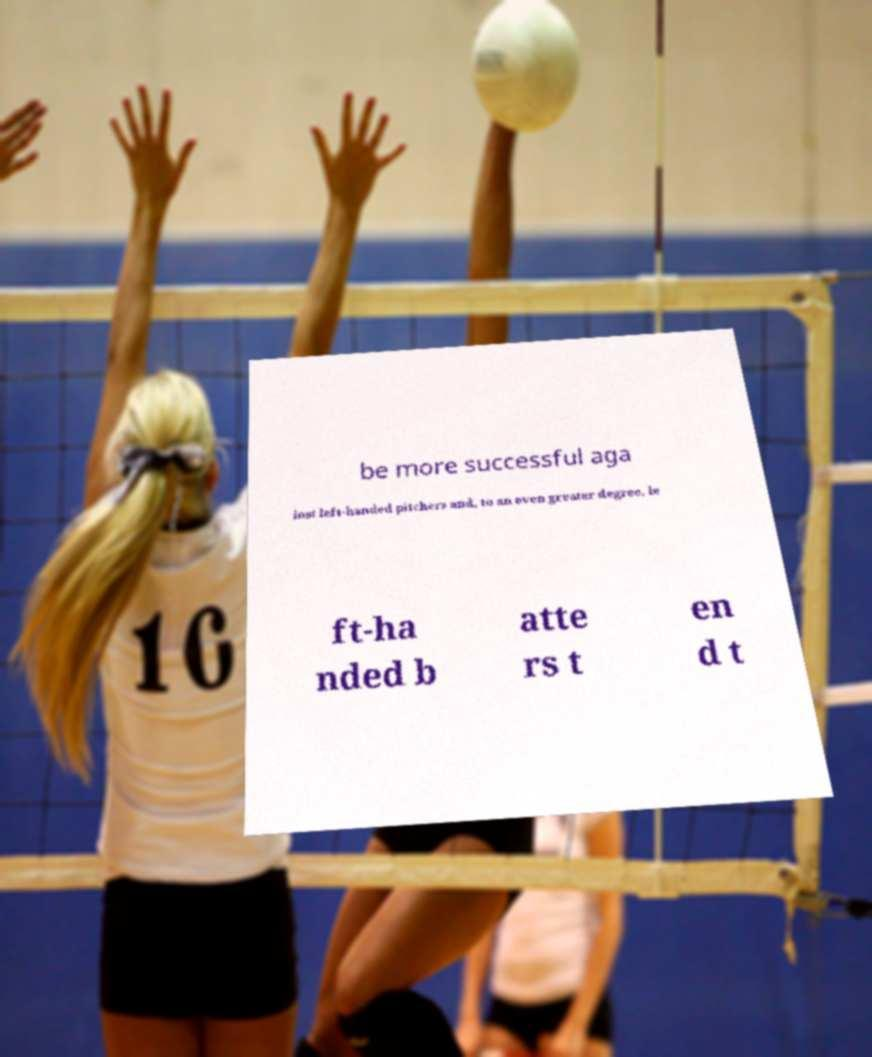Please identify and transcribe the text found in this image. be more successful aga inst left-handed pitchers and, to an even greater degree, le ft-ha nded b atte rs t en d t 